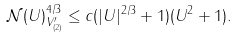Convert formula to latex. <formula><loc_0><loc_0><loc_500><loc_500>\| \mathcal { N } ( U ) \| _ { V _ { ( 2 ) } ^ { \prime } } ^ { 4 / 3 } \leq c ( | U | ^ { 2 / 3 } + 1 ) ( \| U \| ^ { 2 } + 1 ) .</formula> 